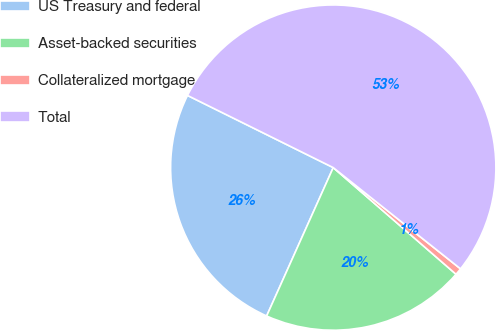Convert chart. <chart><loc_0><loc_0><loc_500><loc_500><pie_chart><fcel>US Treasury and federal<fcel>Asset-backed securities<fcel>Collateralized mortgage<fcel>Total<nl><fcel>25.6%<fcel>20.33%<fcel>0.69%<fcel>53.37%<nl></chart> 